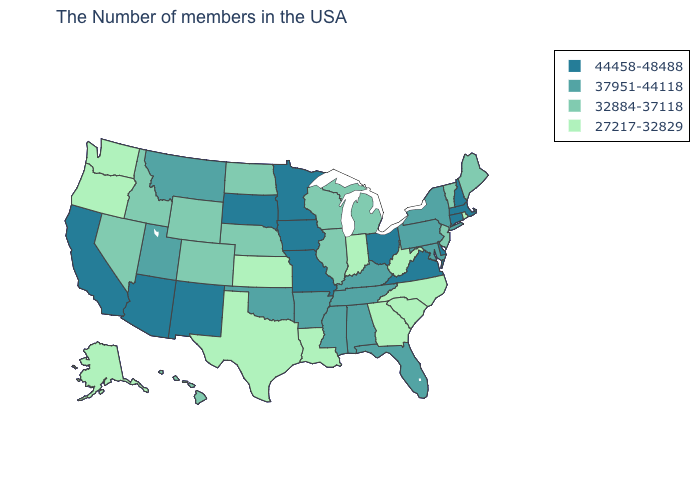Is the legend a continuous bar?
Be succinct. No. Does Massachusetts have a lower value than New Hampshire?
Give a very brief answer. No. How many symbols are there in the legend?
Be succinct. 4. Name the states that have a value in the range 37951-44118?
Write a very short answer. New York, Maryland, Pennsylvania, Florida, Kentucky, Alabama, Tennessee, Mississippi, Arkansas, Oklahoma, Utah, Montana. What is the highest value in the USA?
Be succinct. 44458-48488. Does Alaska have the lowest value in the USA?
Be succinct. Yes. Is the legend a continuous bar?
Answer briefly. No. What is the lowest value in states that border North Dakota?
Be succinct. 37951-44118. What is the lowest value in the South?
Quick response, please. 27217-32829. Which states have the lowest value in the USA?
Keep it brief. Rhode Island, North Carolina, South Carolina, West Virginia, Georgia, Indiana, Louisiana, Kansas, Texas, Washington, Oregon, Alaska. Does Kentucky have the lowest value in the South?
Write a very short answer. No. Is the legend a continuous bar?
Write a very short answer. No. Among the states that border Nebraska , which have the highest value?
Keep it brief. Missouri, Iowa, South Dakota. Name the states that have a value in the range 44458-48488?
Keep it brief. Massachusetts, New Hampshire, Connecticut, Delaware, Virginia, Ohio, Missouri, Minnesota, Iowa, South Dakota, New Mexico, Arizona, California. 